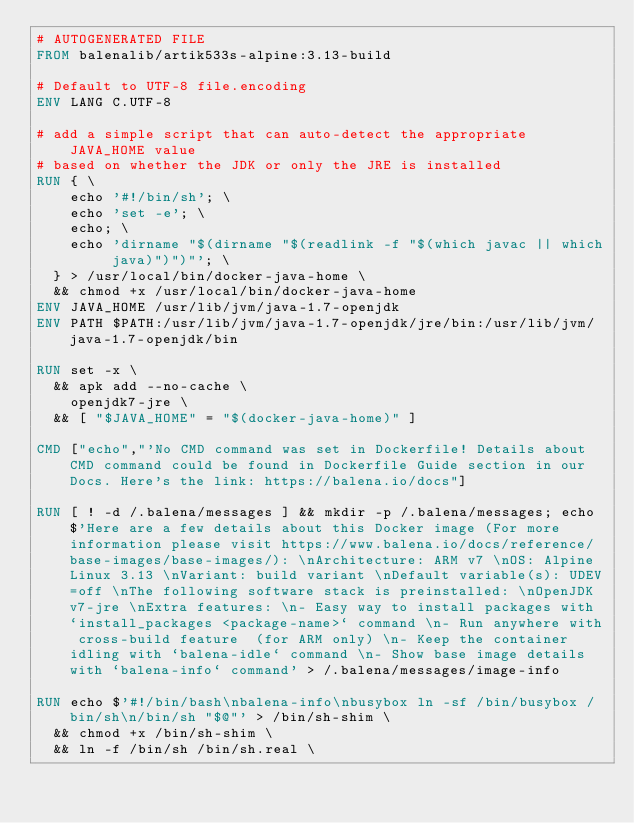<code> <loc_0><loc_0><loc_500><loc_500><_Dockerfile_># AUTOGENERATED FILE
FROM balenalib/artik533s-alpine:3.13-build

# Default to UTF-8 file.encoding
ENV LANG C.UTF-8

# add a simple script that can auto-detect the appropriate JAVA_HOME value
# based on whether the JDK or only the JRE is installed
RUN { \
		echo '#!/bin/sh'; \
		echo 'set -e'; \
		echo; \
		echo 'dirname "$(dirname "$(readlink -f "$(which javac || which java)")")"'; \
	} > /usr/local/bin/docker-java-home \
	&& chmod +x /usr/local/bin/docker-java-home
ENV JAVA_HOME /usr/lib/jvm/java-1.7-openjdk
ENV PATH $PATH:/usr/lib/jvm/java-1.7-openjdk/jre/bin:/usr/lib/jvm/java-1.7-openjdk/bin

RUN set -x \
	&& apk add --no-cache \
		openjdk7-jre \
	&& [ "$JAVA_HOME" = "$(docker-java-home)" ]

CMD ["echo","'No CMD command was set in Dockerfile! Details about CMD command could be found in Dockerfile Guide section in our Docs. Here's the link: https://balena.io/docs"]

RUN [ ! -d /.balena/messages ] && mkdir -p /.balena/messages; echo $'Here are a few details about this Docker image (For more information please visit https://www.balena.io/docs/reference/base-images/base-images/): \nArchitecture: ARM v7 \nOS: Alpine Linux 3.13 \nVariant: build variant \nDefault variable(s): UDEV=off \nThe following software stack is preinstalled: \nOpenJDK v7-jre \nExtra features: \n- Easy way to install packages with `install_packages <package-name>` command \n- Run anywhere with cross-build feature  (for ARM only) \n- Keep the container idling with `balena-idle` command \n- Show base image details with `balena-info` command' > /.balena/messages/image-info

RUN echo $'#!/bin/bash\nbalena-info\nbusybox ln -sf /bin/busybox /bin/sh\n/bin/sh "$@"' > /bin/sh-shim \
	&& chmod +x /bin/sh-shim \
	&& ln -f /bin/sh /bin/sh.real \</code> 